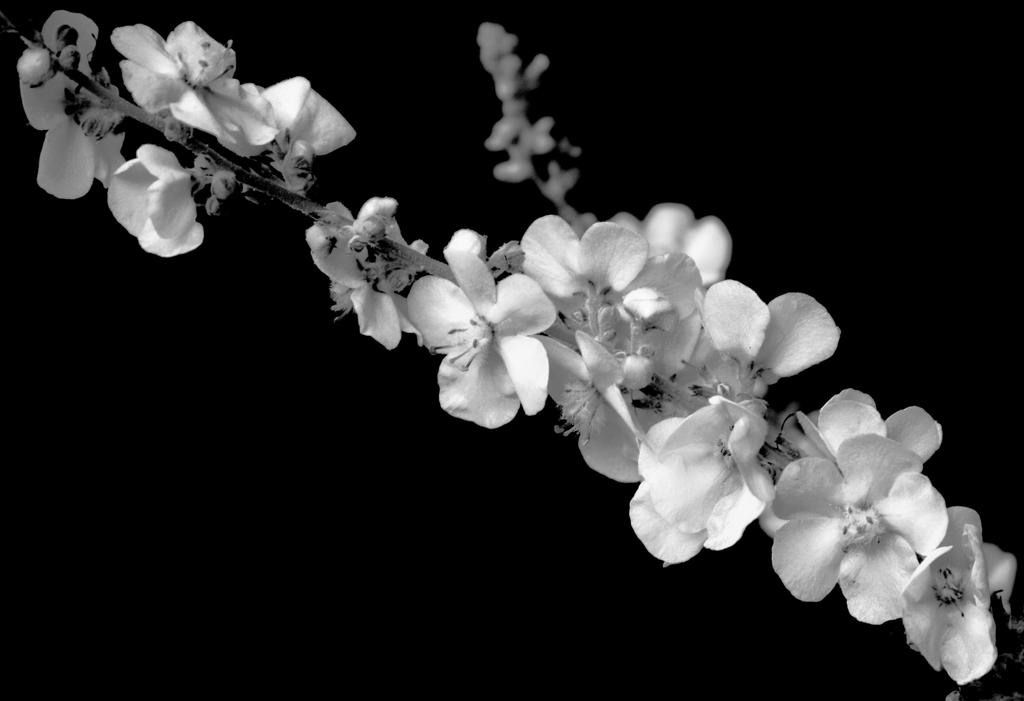What type of plant is visible in the image? The image features a plant with flowers on its branch. Can you describe the flowers on the plant? The flowers are visible on the branch of the plant. What type of crown is the coach wearing while riding the bike in the image? There is no crown, coach, or bike present in the image; it only features a plant with flowers on its branch. 